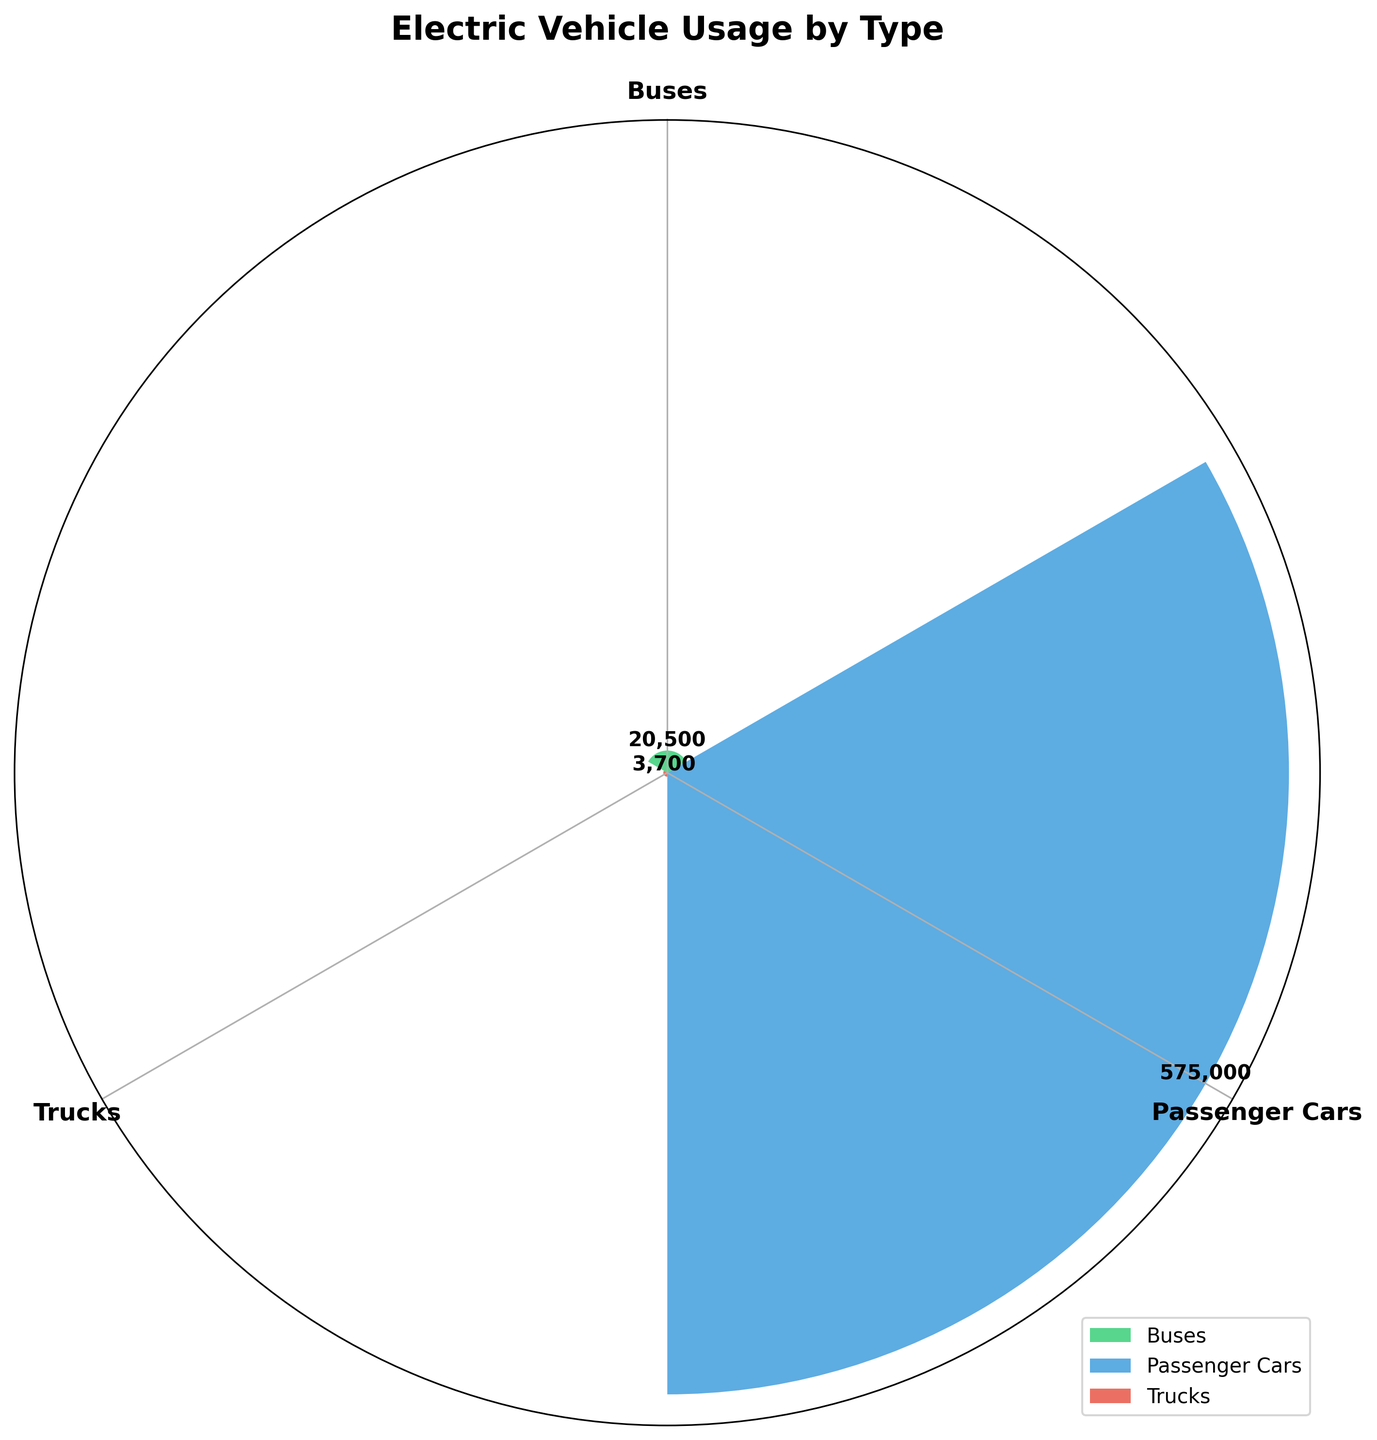Which type of electric vehicle has the highest number of vehicles? The rose chart shows different categories with varying radii. The type with the longest bar represents the highest number of vehicles. The largest bar belongs to Passenger Cars.
Answer: Passenger Cars What is the total number of electric vehicles for Trucks? To obtain the total for Trucks, refer to the height of the Trucks bar and the label next to it. The chart shows that the total number of Trucks is the sum: Tesla Semi (1500) + Rivian R1T (1200) + Volvo VNR Electric (1000).
Answer: 3,700 How many data groups are represented in the rose chart? The number of distinct bars represents the number of data groups. Each unique color and angle represents a group. From the chart, there are three groups: Passenger Cars, Buses, and Trucks.
Answer: 3 Which type of electric vehicle has the smallest contribution? Comparing the length of the bars, the smallest bar indicates the type with the fewest vehicles. Trucks have the smallest bar.
Answer: Trucks What is the difference in the number of vehicles between Passenger Cars and Buses? Identify and subtract the total values of Passenger Cars and Buses from the chart. Passenger Cars have 575,000 vehicles and Buses have 20,500 vehicles. Difference = 575,000 - 20,500 = 554,500.
Answer: 554,500 How many passenger car models are included in the data? Count the number of distinct labels for Passenger Cars in the chart. There are three models: Nissan Leaf, Tesla Model 3, and Chevrolet Bolt.
Answer: 3 Which two categories have the closest number of vehicles? Visually compare the lengths of the bars and find the two bars that are most similar in length. The difference between Buses (20,500) and Trucks (3,700) is less than the difference when compared with Passenger Cars.
Answer: Buses and Trucks What is the average number of vehicles for the Buses category? To find the average, add up the number of vehicles for all bus models and then divide by the number of models. There are three bus models with totals of 7,000 + 8,500 + 5,000 = 20,500. The average is 20,500 / 3.
Answer: 6,833 Which group represents more than half of the total vehicles? Compare the length of the bars or directly use the grouping: Passenger Cars (575,000) compared to the sum of Buses (20,500) and Trucks (3,700). Passenger Cars exceed half of the total, as 575,000 is much larger.
Answer: Passenger Cars What is the combined total of electric vehicles across all types? Sum up the total vehicles for each type: Passenger Cars (575,000), Buses (20,500), and Trucks (3,700). Total = 575,000 + 20,500 + 3,700.
Answer: 599,200 